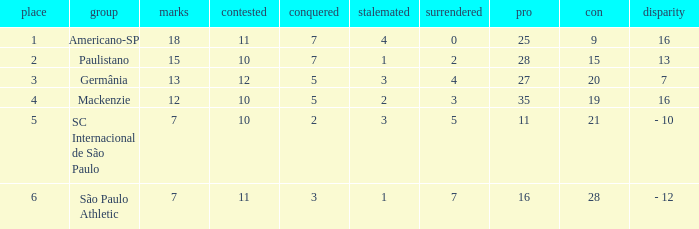Name the least for when played is 12 27.0. 